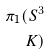<formula> <loc_0><loc_0><loc_500><loc_500>\pi _ { 1 } ( S ^ { 3 } \\ K )</formula> 